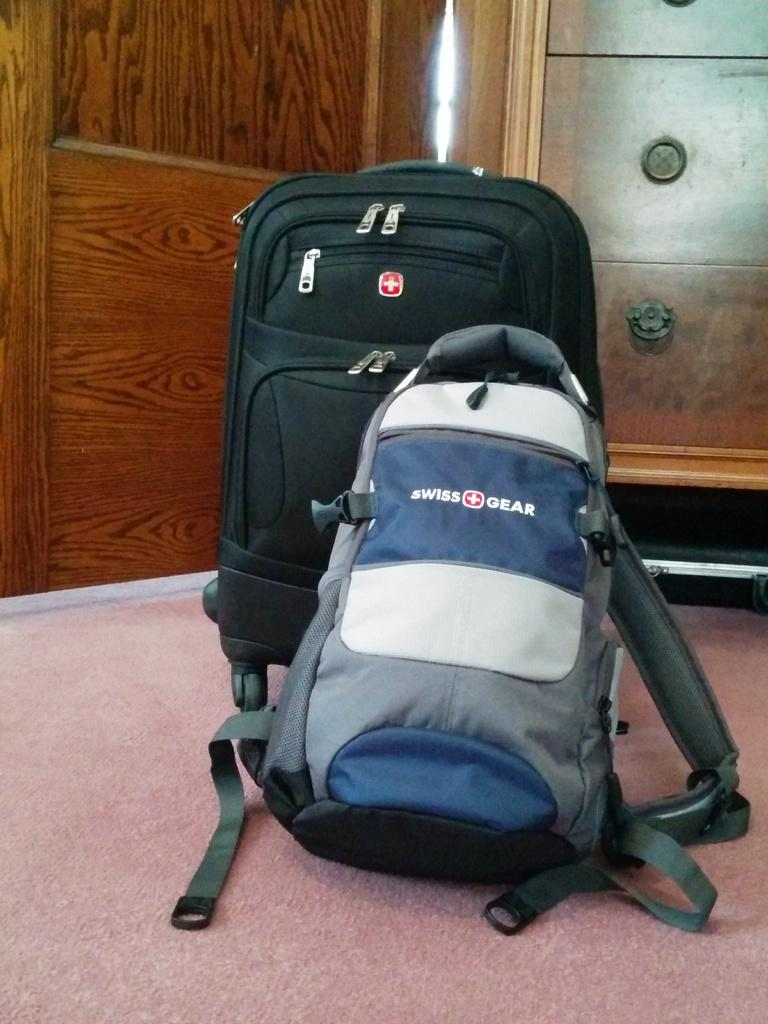What colors are present on the bag in the image? The bag in the image is blue, white, and grey. What type of luggage is also visible in the image? There is a black suitcase in the image. Where are the bag and suitcase located in the image? Both the bag and suitcase are on the floor. What can be seen in the background of the image? There is a wooden wall and a drawer in the background of the image. What type of floor covering is visible in the image? There is a floor mat visible in the image. What type of music is playing in the background of the image? There is no music playing in the background of the image; it is a still image. What type of house is depicted in the image? The image does not depict a house; it only shows a bag, suitcase, and some background elements. 